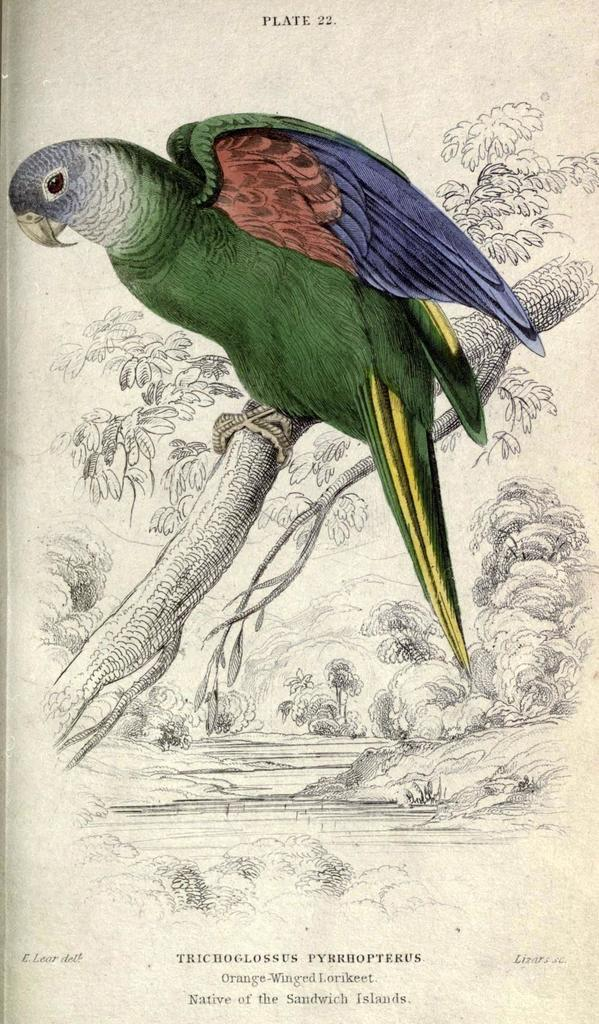What is the main subject of the image? There is a picture in the image. What is depicted in the picture? The picture contains a green color parrot. Where is the parrot located in the picture? The parrot is sitting on a branch. What color is the paint used to create the parrot's mom in the image? There is no mention of a parrot's mom in the image, and no paint is visible. Can you tell me how many donkeys are present in the image? There are no donkeys present in the image; it features a picture of a green parrot sitting on a branch. 